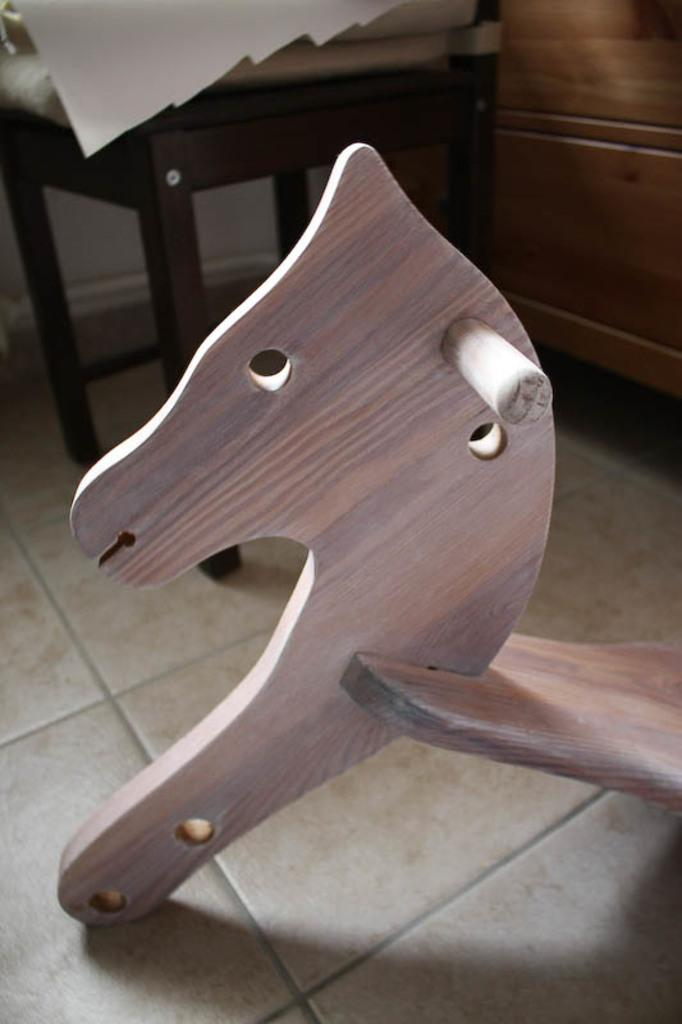What type of furniture is present in the image? There is a chair in the image. What material are the objects on the floor made of? The objects on the floor are made of wood. Can you hear the bells ringing in the image? There are no bells present in the image, so it is not possible to hear them ringing. Does the existence of the chair in the image prove the existence of life on other planets? The existence of the chair in the image does not prove the existence of life on other planets, as it is an object on Earth. What is the tongue doing in the image? There is no tongue present in the image. 